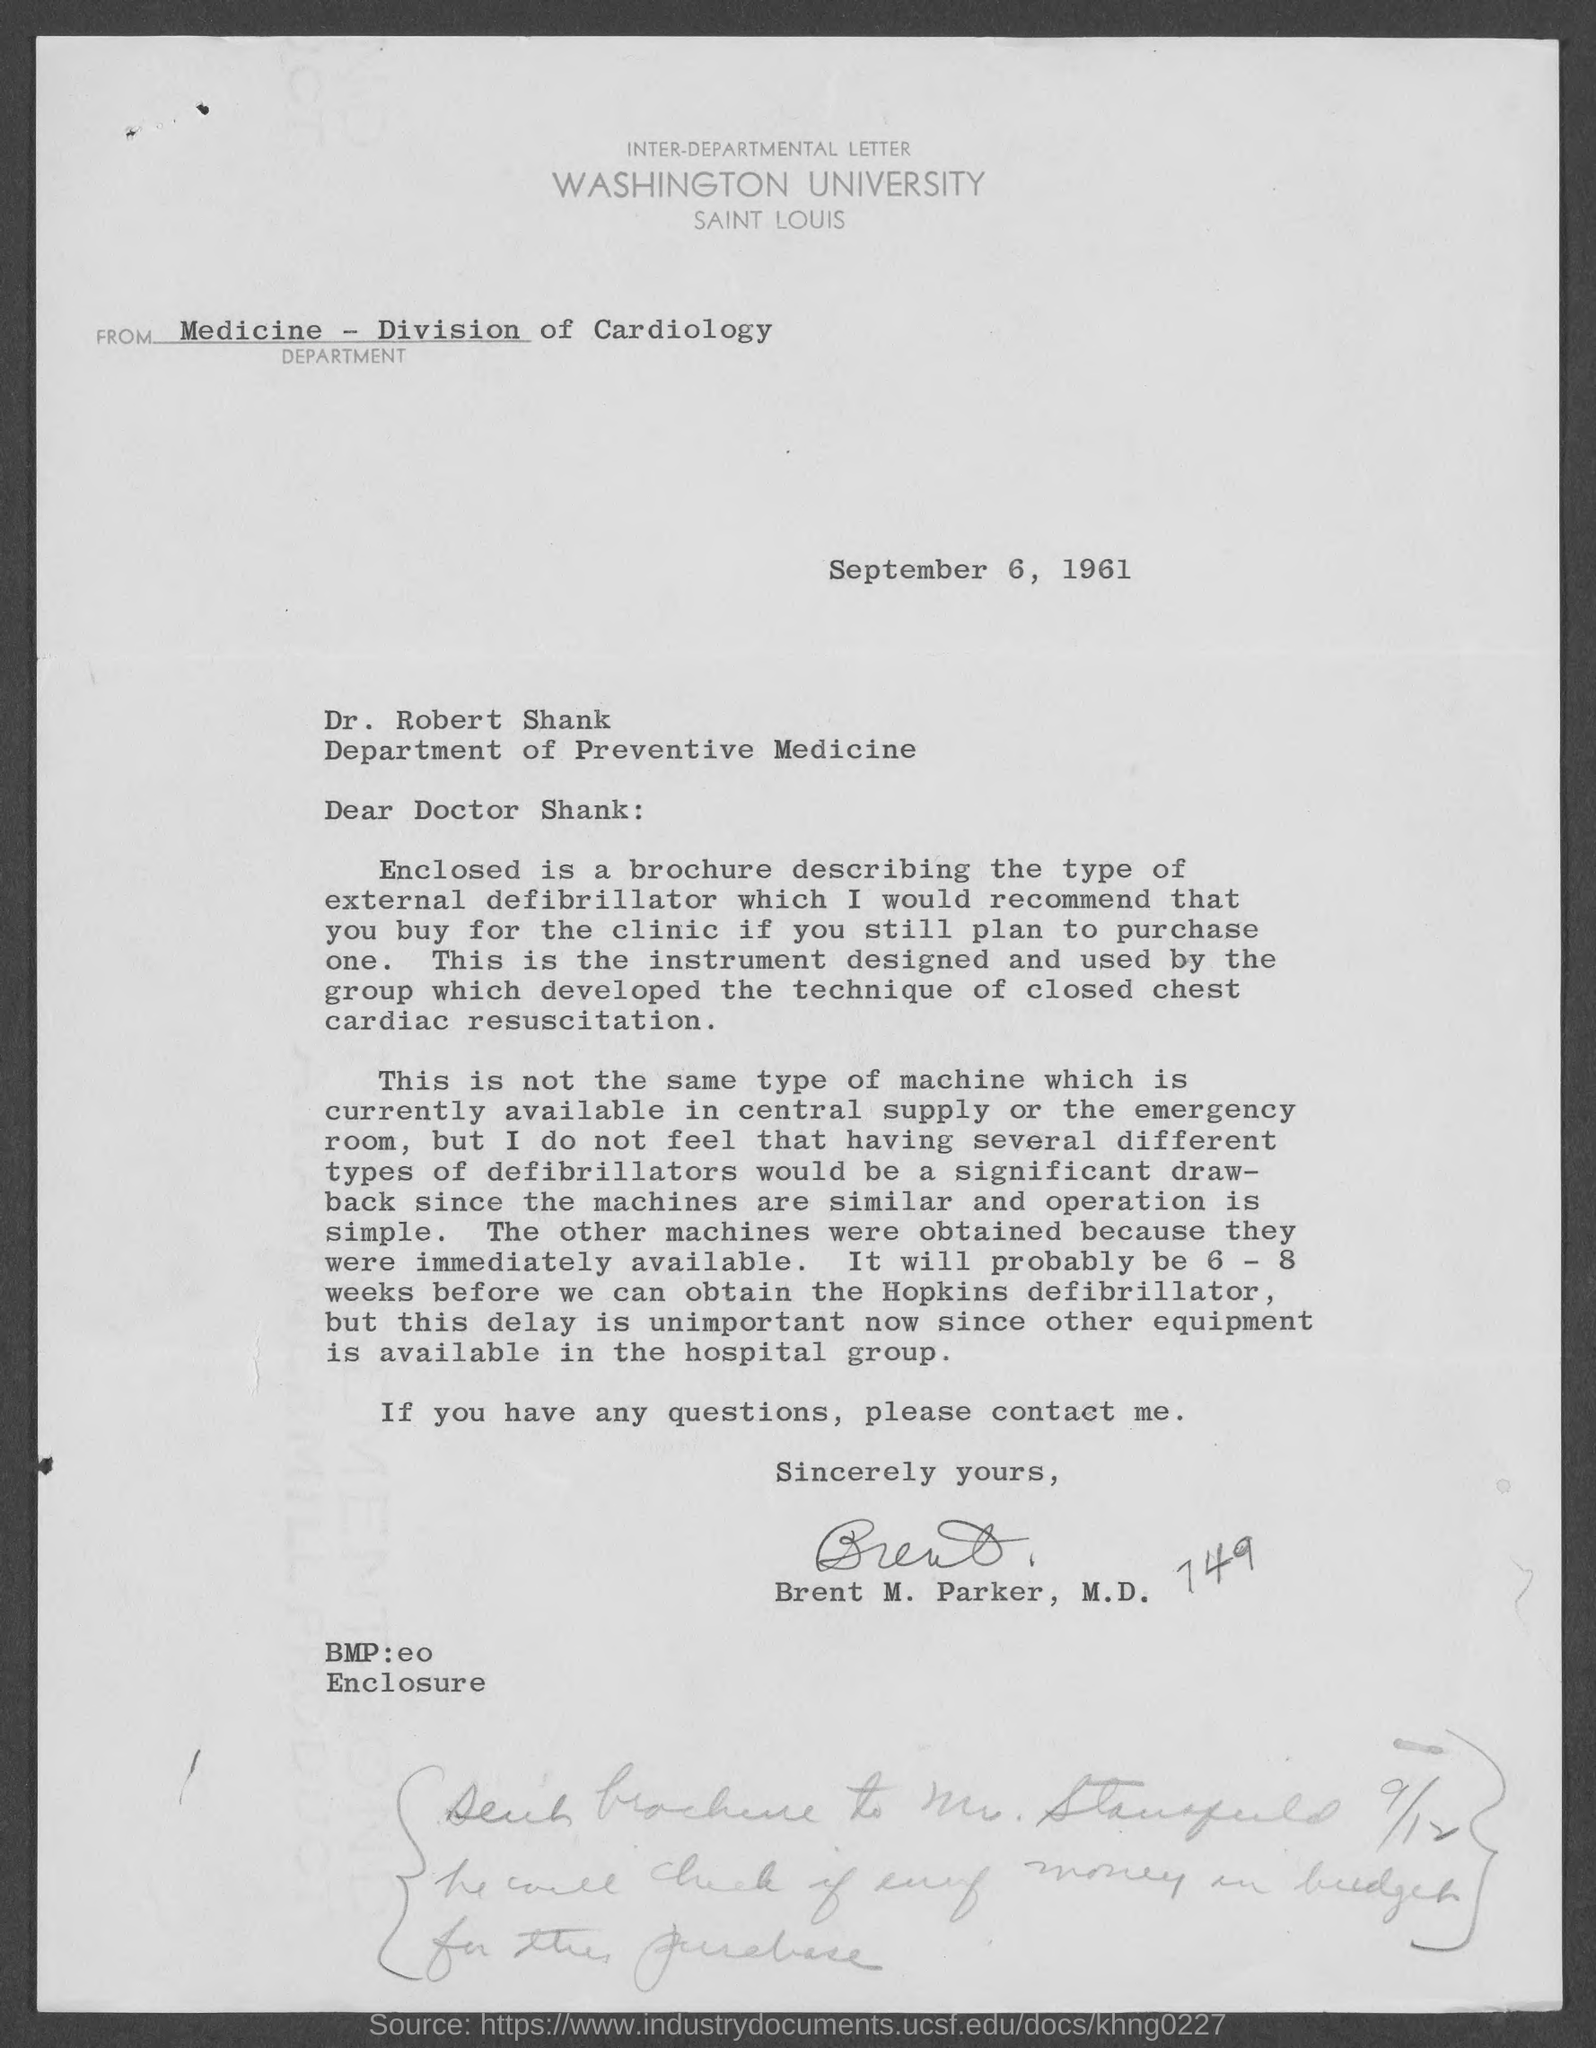Specify some key components in this picture. Dr. Robert Shank belongs to the Department of Preventive Medicine. The date mentioned in the given letter is September 6, 1961. The signature at the end of the letter was that of Brent M. Parker. The division mentioned in the given letter is the Division of Cardiology. This letter was written to DR. ROBERT SHANK. 